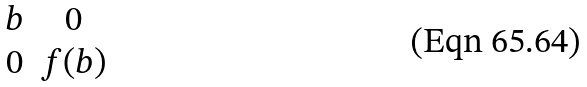Convert formula to latex. <formula><loc_0><loc_0><loc_500><loc_500>\begin{matrix} b & 0 \\ 0 & f ( b ) \end{matrix}</formula> 